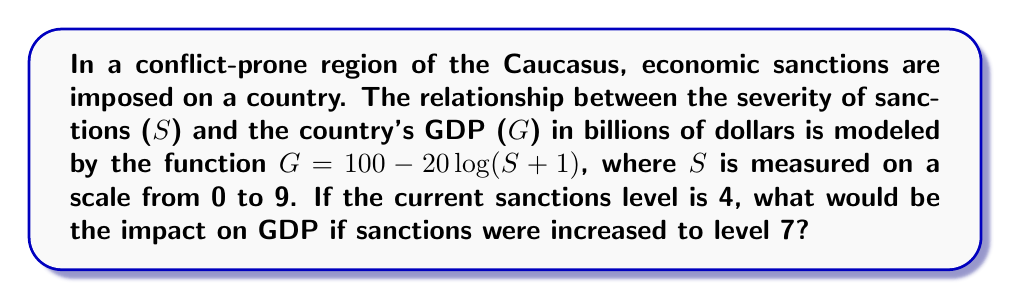What is the answer to this math problem? 1) First, we need to calculate the GDP at the current sanctions level (S = 4):
   $G_1 = 100 - 20\log(4+1)$
   $G_1 = 100 - 20\log(5)$
   $G_1 = 100 - 20 \cdot 0.699$
   $G_1 = 86.02$ billion dollars

2) Next, we calculate the GDP if sanctions were increased to level 7:
   $G_2 = 100 - 20\log(7+1)$
   $G_2 = 100 - 20\log(8)$
   $G_2 = 100 - 20 \cdot 0.903$
   $G_2 = 81.94$ billion dollars

3) To find the impact, we subtract the new GDP from the current GDP:
   Impact = $G_1 - G_2$
   Impact = $86.02 - 81.94$
   Impact = $4.08$ billion dollars
Answer: $4.08 billion 